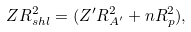Convert formula to latex. <formula><loc_0><loc_0><loc_500><loc_500>Z R _ { s h l } ^ { 2 } = ( Z ^ { \prime } R _ { A ^ { \prime } } ^ { 2 } + n R _ { p } ^ { 2 } ) ,</formula> 